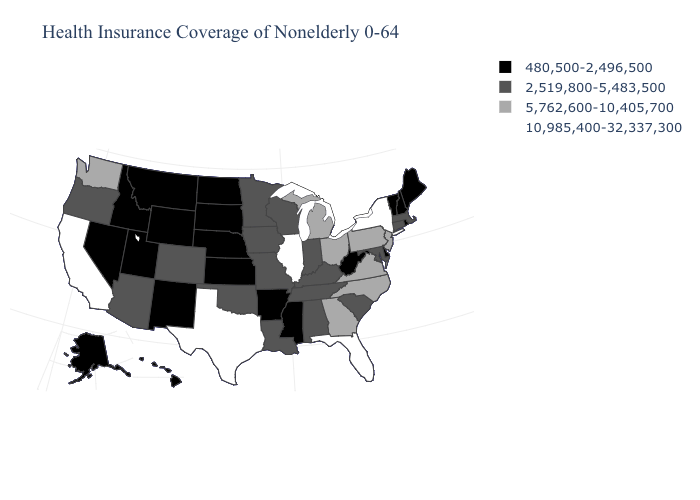Name the states that have a value in the range 2,519,800-5,483,500?
Concise answer only. Alabama, Arizona, Colorado, Connecticut, Indiana, Iowa, Kentucky, Louisiana, Maryland, Massachusetts, Minnesota, Missouri, Oklahoma, Oregon, South Carolina, Tennessee, Wisconsin. Does the first symbol in the legend represent the smallest category?
Quick response, please. Yes. What is the highest value in states that border Indiana?
Write a very short answer. 10,985,400-32,337,300. What is the highest value in the USA?
Keep it brief. 10,985,400-32,337,300. Name the states that have a value in the range 5,762,600-10,405,700?
Keep it brief. Georgia, Michigan, New Jersey, North Carolina, Ohio, Pennsylvania, Virginia, Washington. What is the highest value in the Northeast ?
Give a very brief answer. 10,985,400-32,337,300. What is the lowest value in states that border Missouri?
Be succinct. 480,500-2,496,500. Among the states that border Ohio , which have the lowest value?
Give a very brief answer. West Virginia. What is the value of New Jersey?
Keep it brief. 5,762,600-10,405,700. What is the value of Alabama?
Be succinct. 2,519,800-5,483,500. What is the highest value in states that border Arkansas?
Answer briefly. 10,985,400-32,337,300. Does Illinois have the highest value in the USA?
Be succinct. Yes. Among the states that border Maryland , which have the lowest value?
Keep it brief. Delaware, West Virginia. What is the value of Maine?
Keep it brief. 480,500-2,496,500. 